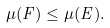<formula> <loc_0><loc_0><loc_500><loc_500>\mu ( F ) \leq \mu ( E ) .</formula> 